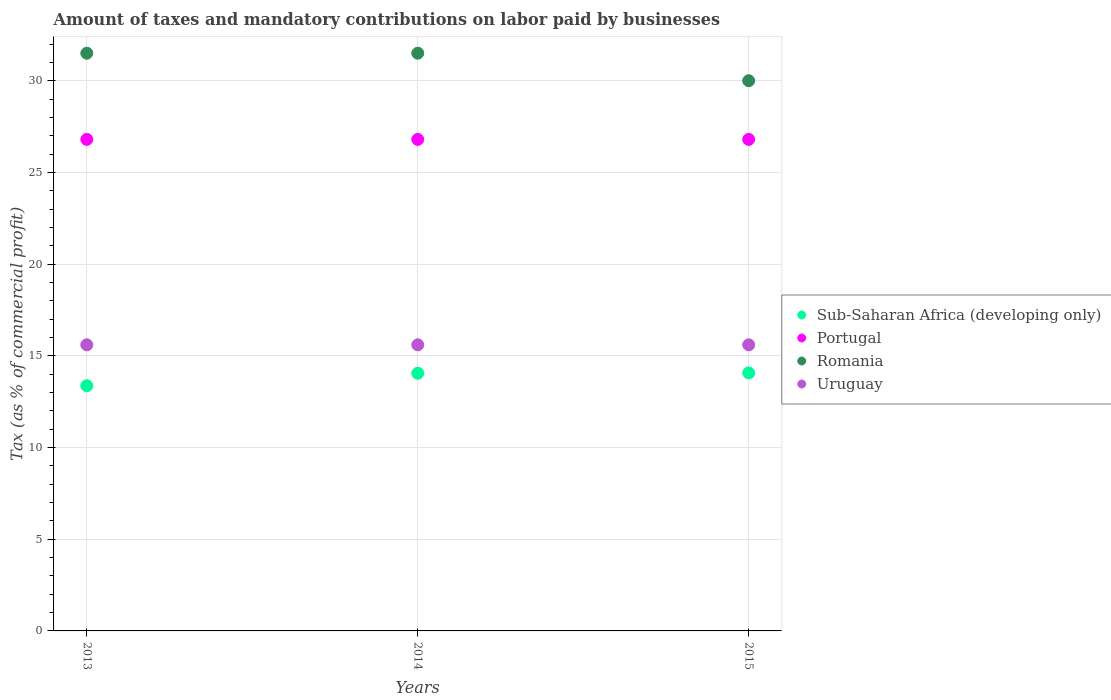How many different coloured dotlines are there?
Make the answer very short. 4. Is the number of dotlines equal to the number of legend labels?
Offer a very short reply. Yes. Across all years, what is the maximum percentage of taxes paid by businesses in Uruguay?
Your answer should be very brief. 15.6. In which year was the percentage of taxes paid by businesses in Romania maximum?
Your answer should be compact. 2013. In which year was the percentage of taxes paid by businesses in Portugal minimum?
Provide a succinct answer. 2013. What is the total percentage of taxes paid by businesses in Uruguay in the graph?
Your answer should be very brief. 46.8. What is the difference between the percentage of taxes paid by businesses in Uruguay in 2013 and that in 2014?
Offer a very short reply. 0. In the year 2015, what is the difference between the percentage of taxes paid by businesses in Romania and percentage of taxes paid by businesses in Portugal?
Provide a short and direct response. 3.2. What is the ratio of the percentage of taxes paid by businesses in Uruguay in 2013 to that in 2015?
Ensure brevity in your answer.  1. Is the percentage of taxes paid by businesses in Uruguay in 2013 less than that in 2015?
Provide a short and direct response. No. What is the difference between the highest and the second highest percentage of taxes paid by businesses in Portugal?
Keep it short and to the point. 0. Is the percentage of taxes paid by businesses in Uruguay strictly greater than the percentage of taxes paid by businesses in Sub-Saharan Africa (developing only) over the years?
Offer a very short reply. Yes. Is the percentage of taxes paid by businesses in Romania strictly less than the percentage of taxes paid by businesses in Portugal over the years?
Offer a terse response. No. How many dotlines are there?
Your response must be concise. 4. Are the values on the major ticks of Y-axis written in scientific E-notation?
Offer a very short reply. No. Where does the legend appear in the graph?
Keep it short and to the point. Center right. How many legend labels are there?
Your answer should be compact. 4. How are the legend labels stacked?
Offer a terse response. Vertical. What is the title of the graph?
Ensure brevity in your answer.  Amount of taxes and mandatory contributions on labor paid by businesses. What is the label or title of the X-axis?
Your response must be concise. Years. What is the label or title of the Y-axis?
Your response must be concise. Tax (as % of commercial profit). What is the Tax (as % of commercial profit) of Sub-Saharan Africa (developing only) in 2013?
Your response must be concise. 13.37. What is the Tax (as % of commercial profit) of Portugal in 2013?
Your response must be concise. 26.8. What is the Tax (as % of commercial profit) in Romania in 2013?
Provide a succinct answer. 31.5. What is the Tax (as % of commercial profit) of Sub-Saharan Africa (developing only) in 2014?
Offer a very short reply. 14.05. What is the Tax (as % of commercial profit) of Portugal in 2014?
Your response must be concise. 26.8. What is the Tax (as % of commercial profit) of Romania in 2014?
Provide a short and direct response. 31.5. What is the Tax (as % of commercial profit) in Uruguay in 2014?
Your answer should be compact. 15.6. What is the Tax (as % of commercial profit) of Sub-Saharan Africa (developing only) in 2015?
Offer a terse response. 14.07. What is the Tax (as % of commercial profit) of Portugal in 2015?
Your answer should be very brief. 26.8. What is the Tax (as % of commercial profit) in Romania in 2015?
Ensure brevity in your answer.  30. Across all years, what is the maximum Tax (as % of commercial profit) in Sub-Saharan Africa (developing only)?
Give a very brief answer. 14.07. Across all years, what is the maximum Tax (as % of commercial profit) of Portugal?
Your answer should be compact. 26.8. Across all years, what is the maximum Tax (as % of commercial profit) in Romania?
Your answer should be very brief. 31.5. Across all years, what is the maximum Tax (as % of commercial profit) in Uruguay?
Your answer should be compact. 15.6. Across all years, what is the minimum Tax (as % of commercial profit) in Sub-Saharan Africa (developing only)?
Keep it short and to the point. 13.37. Across all years, what is the minimum Tax (as % of commercial profit) in Portugal?
Offer a very short reply. 26.8. Across all years, what is the minimum Tax (as % of commercial profit) in Romania?
Offer a terse response. 30. What is the total Tax (as % of commercial profit) in Sub-Saharan Africa (developing only) in the graph?
Provide a short and direct response. 41.49. What is the total Tax (as % of commercial profit) of Portugal in the graph?
Keep it short and to the point. 80.4. What is the total Tax (as % of commercial profit) of Romania in the graph?
Provide a succinct answer. 93. What is the total Tax (as % of commercial profit) of Uruguay in the graph?
Provide a succinct answer. 46.8. What is the difference between the Tax (as % of commercial profit) of Sub-Saharan Africa (developing only) in 2013 and that in 2014?
Keep it short and to the point. -0.68. What is the difference between the Tax (as % of commercial profit) in Romania in 2013 and that in 2014?
Give a very brief answer. 0. What is the difference between the Tax (as % of commercial profit) in Uruguay in 2013 and that in 2014?
Your answer should be compact. 0. What is the difference between the Tax (as % of commercial profit) of Sub-Saharan Africa (developing only) in 2013 and that in 2015?
Offer a very short reply. -0.7. What is the difference between the Tax (as % of commercial profit) in Sub-Saharan Africa (developing only) in 2014 and that in 2015?
Provide a succinct answer. -0.02. What is the difference between the Tax (as % of commercial profit) in Portugal in 2014 and that in 2015?
Provide a short and direct response. 0. What is the difference between the Tax (as % of commercial profit) in Romania in 2014 and that in 2015?
Your answer should be compact. 1.5. What is the difference between the Tax (as % of commercial profit) in Uruguay in 2014 and that in 2015?
Offer a very short reply. 0. What is the difference between the Tax (as % of commercial profit) in Sub-Saharan Africa (developing only) in 2013 and the Tax (as % of commercial profit) in Portugal in 2014?
Your response must be concise. -13.43. What is the difference between the Tax (as % of commercial profit) in Sub-Saharan Africa (developing only) in 2013 and the Tax (as % of commercial profit) in Romania in 2014?
Your answer should be very brief. -18.13. What is the difference between the Tax (as % of commercial profit) of Sub-Saharan Africa (developing only) in 2013 and the Tax (as % of commercial profit) of Uruguay in 2014?
Offer a very short reply. -2.23. What is the difference between the Tax (as % of commercial profit) of Sub-Saharan Africa (developing only) in 2013 and the Tax (as % of commercial profit) of Portugal in 2015?
Provide a short and direct response. -13.43. What is the difference between the Tax (as % of commercial profit) in Sub-Saharan Africa (developing only) in 2013 and the Tax (as % of commercial profit) in Romania in 2015?
Your answer should be compact. -16.63. What is the difference between the Tax (as % of commercial profit) of Sub-Saharan Africa (developing only) in 2013 and the Tax (as % of commercial profit) of Uruguay in 2015?
Provide a succinct answer. -2.23. What is the difference between the Tax (as % of commercial profit) of Portugal in 2013 and the Tax (as % of commercial profit) of Romania in 2015?
Offer a very short reply. -3.2. What is the difference between the Tax (as % of commercial profit) of Romania in 2013 and the Tax (as % of commercial profit) of Uruguay in 2015?
Your answer should be compact. 15.9. What is the difference between the Tax (as % of commercial profit) in Sub-Saharan Africa (developing only) in 2014 and the Tax (as % of commercial profit) in Portugal in 2015?
Provide a succinct answer. -12.75. What is the difference between the Tax (as % of commercial profit) in Sub-Saharan Africa (developing only) in 2014 and the Tax (as % of commercial profit) in Romania in 2015?
Your response must be concise. -15.95. What is the difference between the Tax (as % of commercial profit) of Sub-Saharan Africa (developing only) in 2014 and the Tax (as % of commercial profit) of Uruguay in 2015?
Offer a terse response. -1.55. What is the difference between the Tax (as % of commercial profit) of Portugal in 2014 and the Tax (as % of commercial profit) of Romania in 2015?
Your answer should be very brief. -3.2. What is the difference between the Tax (as % of commercial profit) in Portugal in 2014 and the Tax (as % of commercial profit) in Uruguay in 2015?
Your answer should be compact. 11.2. What is the difference between the Tax (as % of commercial profit) of Romania in 2014 and the Tax (as % of commercial profit) of Uruguay in 2015?
Offer a terse response. 15.9. What is the average Tax (as % of commercial profit) in Sub-Saharan Africa (developing only) per year?
Make the answer very short. 13.83. What is the average Tax (as % of commercial profit) of Portugal per year?
Provide a succinct answer. 26.8. What is the average Tax (as % of commercial profit) in Romania per year?
Offer a very short reply. 31. What is the average Tax (as % of commercial profit) of Uruguay per year?
Keep it short and to the point. 15.6. In the year 2013, what is the difference between the Tax (as % of commercial profit) in Sub-Saharan Africa (developing only) and Tax (as % of commercial profit) in Portugal?
Provide a short and direct response. -13.43. In the year 2013, what is the difference between the Tax (as % of commercial profit) of Sub-Saharan Africa (developing only) and Tax (as % of commercial profit) of Romania?
Provide a succinct answer. -18.13. In the year 2013, what is the difference between the Tax (as % of commercial profit) in Sub-Saharan Africa (developing only) and Tax (as % of commercial profit) in Uruguay?
Ensure brevity in your answer.  -2.23. In the year 2013, what is the difference between the Tax (as % of commercial profit) of Portugal and Tax (as % of commercial profit) of Romania?
Give a very brief answer. -4.7. In the year 2013, what is the difference between the Tax (as % of commercial profit) in Portugal and Tax (as % of commercial profit) in Uruguay?
Offer a terse response. 11.2. In the year 2013, what is the difference between the Tax (as % of commercial profit) of Romania and Tax (as % of commercial profit) of Uruguay?
Ensure brevity in your answer.  15.9. In the year 2014, what is the difference between the Tax (as % of commercial profit) in Sub-Saharan Africa (developing only) and Tax (as % of commercial profit) in Portugal?
Your response must be concise. -12.75. In the year 2014, what is the difference between the Tax (as % of commercial profit) of Sub-Saharan Africa (developing only) and Tax (as % of commercial profit) of Romania?
Give a very brief answer. -17.45. In the year 2014, what is the difference between the Tax (as % of commercial profit) in Sub-Saharan Africa (developing only) and Tax (as % of commercial profit) in Uruguay?
Offer a very short reply. -1.55. In the year 2014, what is the difference between the Tax (as % of commercial profit) of Portugal and Tax (as % of commercial profit) of Uruguay?
Give a very brief answer. 11.2. In the year 2014, what is the difference between the Tax (as % of commercial profit) in Romania and Tax (as % of commercial profit) in Uruguay?
Provide a succinct answer. 15.9. In the year 2015, what is the difference between the Tax (as % of commercial profit) in Sub-Saharan Africa (developing only) and Tax (as % of commercial profit) in Portugal?
Your response must be concise. -12.73. In the year 2015, what is the difference between the Tax (as % of commercial profit) of Sub-Saharan Africa (developing only) and Tax (as % of commercial profit) of Romania?
Your response must be concise. -15.93. In the year 2015, what is the difference between the Tax (as % of commercial profit) in Sub-Saharan Africa (developing only) and Tax (as % of commercial profit) in Uruguay?
Ensure brevity in your answer.  -1.53. In the year 2015, what is the difference between the Tax (as % of commercial profit) in Portugal and Tax (as % of commercial profit) in Uruguay?
Make the answer very short. 11.2. What is the ratio of the Tax (as % of commercial profit) in Sub-Saharan Africa (developing only) in 2013 to that in 2014?
Your answer should be very brief. 0.95. What is the ratio of the Tax (as % of commercial profit) in Portugal in 2013 to that in 2014?
Offer a terse response. 1. What is the ratio of the Tax (as % of commercial profit) of Romania in 2013 to that in 2014?
Make the answer very short. 1. What is the ratio of the Tax (as % of commercial profit) of Sub-Saharan Africa (developing only) in 2013 to that in 2015?
Offer a very short reply. 0.95. What is the ratio of the Tax (as % of commercial profit) of Romania in 2013 to that in 2015?
Offer a very short reply. 1.05. What is the ratio of the Tax (as % of commercial profit) in Uruguay in 2013 to that in 2015?
Offer a very short reply. 1. What is the ratio of the Tax (as % of commercial profit) in Sub-Saharan Africa (developing only) in 2014 to that in 2015?
Your answer should be very brief. 1. What is the ratio of the Tax (as % of commercial profit) in Portugal in 2014 to that in 2015?
Make the answer very short. 1. What is the ratio of the Tax (as % of commercial profit) in Romania in 2014 to that in 2015?
Give a very brief answer. 1.05. What is the difference between the highest and the second highest Tax (as % of commercial profit) in Sub-Saharan Africa (developing only)?
Ensure brevity in your answer.  0.02. What is the difference between the highest and the second highest Tax (as % of commercial profit) in Portugal?
Offer a very short reply. 0. What is the difference between the highest and the second highest Tax (as % of commercial profit) in Romania?
Ensure brevity in your answer.  0. What is the difference between the highest and the second highest Tax (as % of commercial profit) in Uruguay?
Keep it short and to the point. 0. What is the difference between the highest and the lowest Tax (as % of commercial profit) of Sub-Saharan Africa (developing only)?
Provide a short and direct response. 0.7. What is the difference between the highest and the lowest Tax (as % of commercial profit) of Romania?
Ensure brevity in your answer.  1.5. What is the difference between the highest and the lowest Tax (as % of commercial profit) of Uruguay?
Offer a very short reply. 0. 